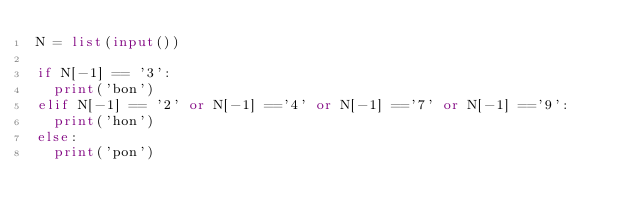<code> <loc_0><loc_0><loc_500><loc_500><_Python_>N = list(input())

if N[-1] == '3':
  print('bon')
elif N[-1] == '2' or N[-1] =='4' or N[-1] =='7' or N[-1] =='9':
  print('hon')
else:
  print('pon')</code> 